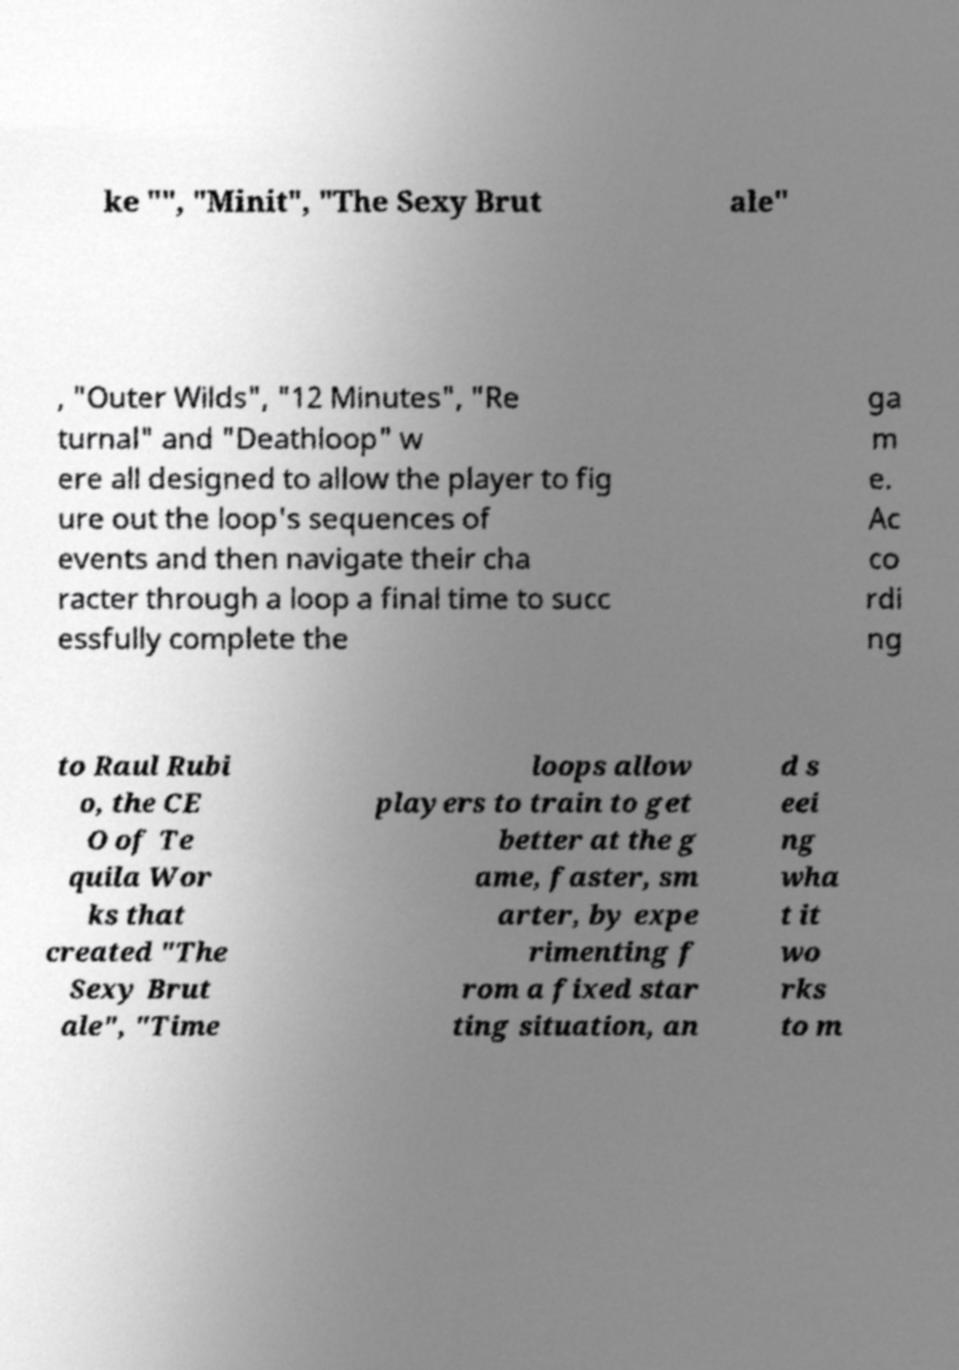There's text embedded in this image that I need extracted. Can you transcribe it verbatim? ke "", "Minit", "The Sexy Brut ale" , "Outer Wilds", "12 Minutes", "Re turnal" and "Deathloop" w ere all designed to allow the player to fig ure out the loop's sequences of events and then navigate their cha racter through a loop a final time to succ essfully complete the ga m e. Ac co rdi ng to Raul Rubi o, the CE O of Te quila Wor ks that created "The Sexy Brut ale", "Time loops allow players to train to get better at the g ame, faster, sm arter, by expe rimenting f rom a fixed star ting situation, an d s eei ng wha t it wo rks to m 